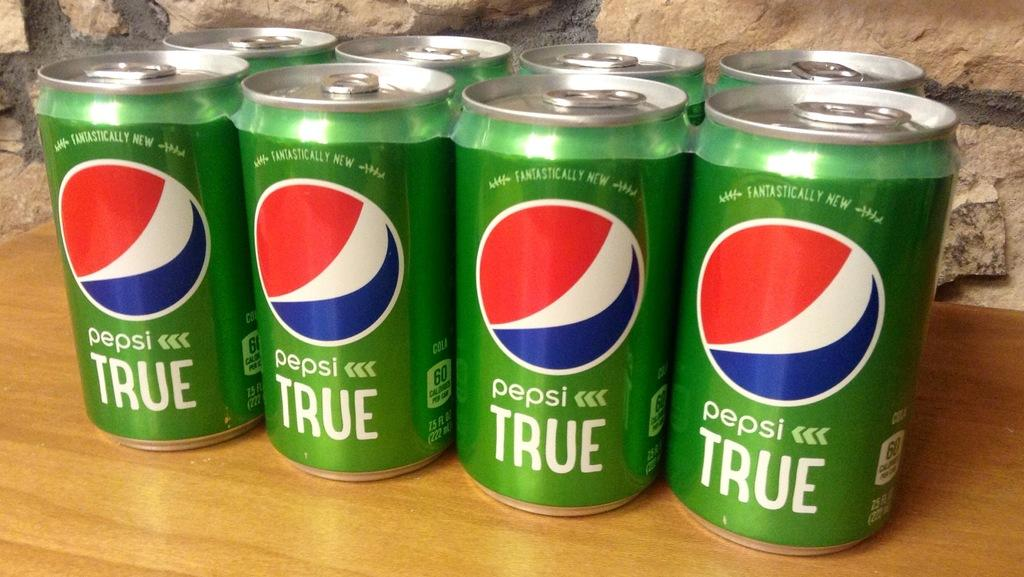Provide a one-sentence caption for the provided image. An eight pack of green Pepsi true in cans. 